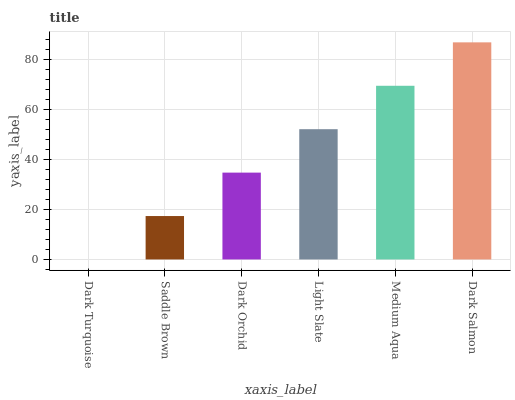Is Dark Turquoise the minimum?
Answer yes or no. Yes. Is Dark Salmon the maximum?
Answer yes or no. Yes. Is Saddle Brown the minimum?
Answer yes or no. No. Is Saddle Brown the maximum?
Answer yes or no. No. Is Saddle Brown greater than Dark Turquoise?
Answer yes or no. Yes. Is Dark Turquoise less than Saddle Brown?
Answer yes or no. Yes. Is Dark Turquoise greater than Saddle Brown?
Answer yes or no. No. Is Saddle Brown less than Dark Turquoise?
Answer yes or no. No. Is Light Slate the high median?
Answer yes or no. Yes. Is Dark Orchid the low median?
Answer yes or no. Yes. Is Dark Orchid the high median?
Answer yes or no. No. Is Light Slate the low median?
Answer yes or no. No. 